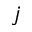<formula> <loc_0><loc_0><loc_500><loc_500>j</formula> 